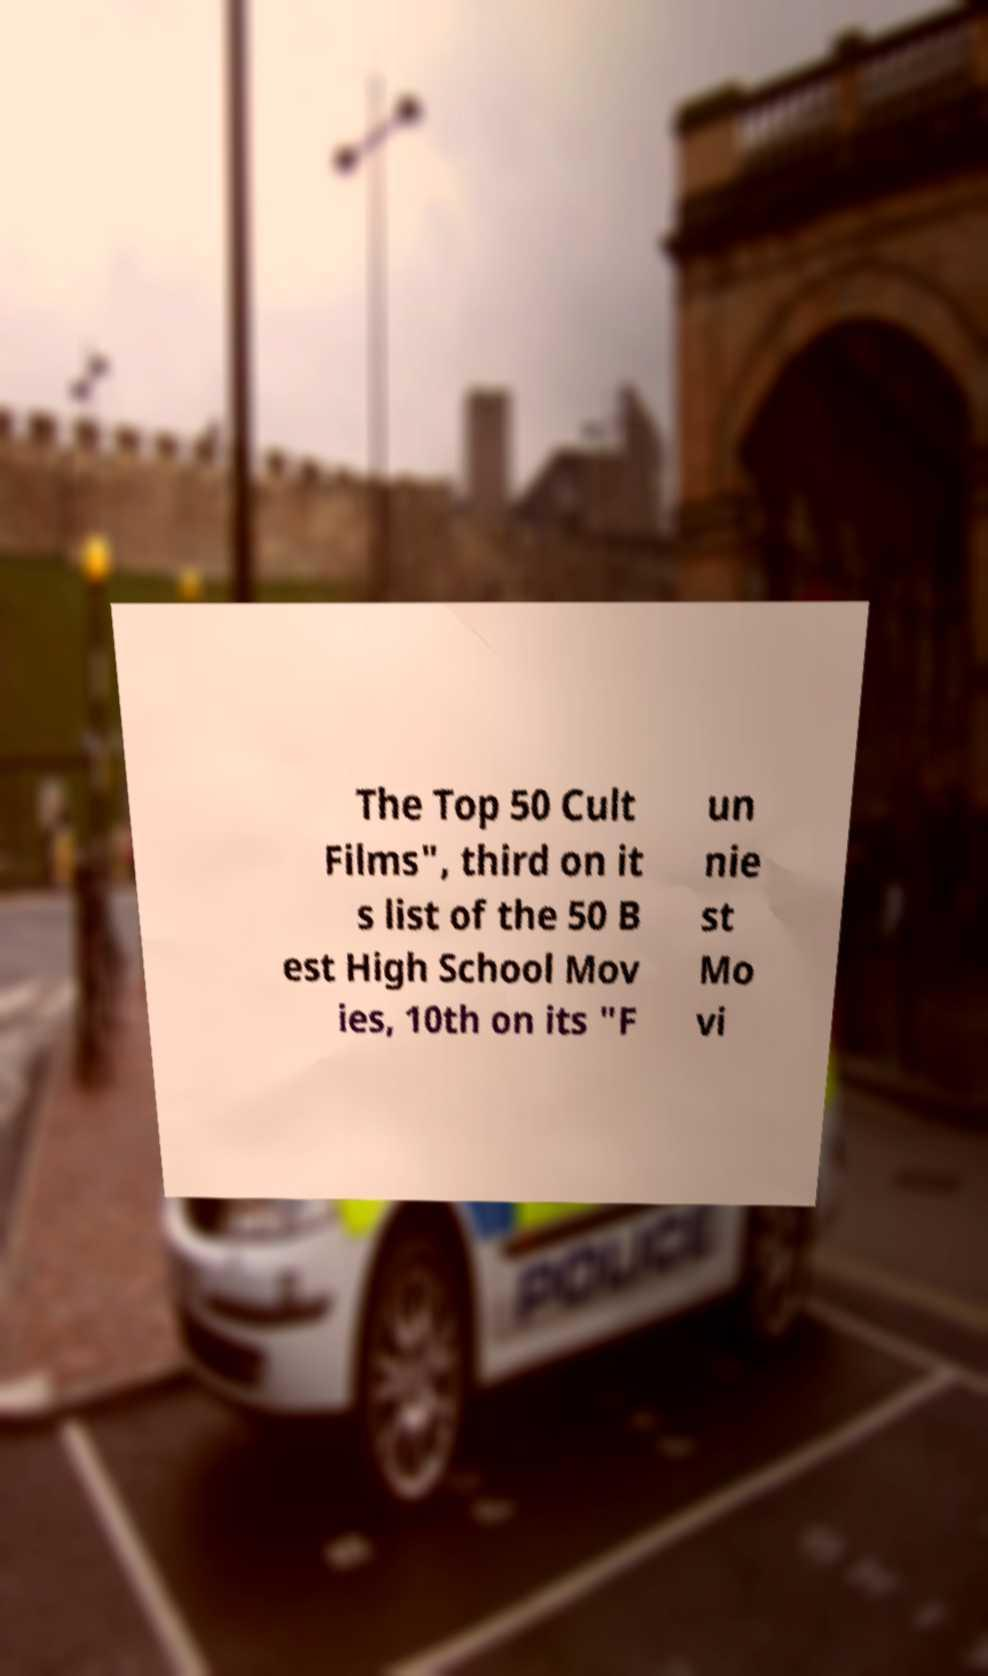Please read and relay the text visible in this image. What does it say? The Top 50 Cult Films", third on it s list of the 50 B est High School Mov ies, 10th on its "F un nie st Mo vi 